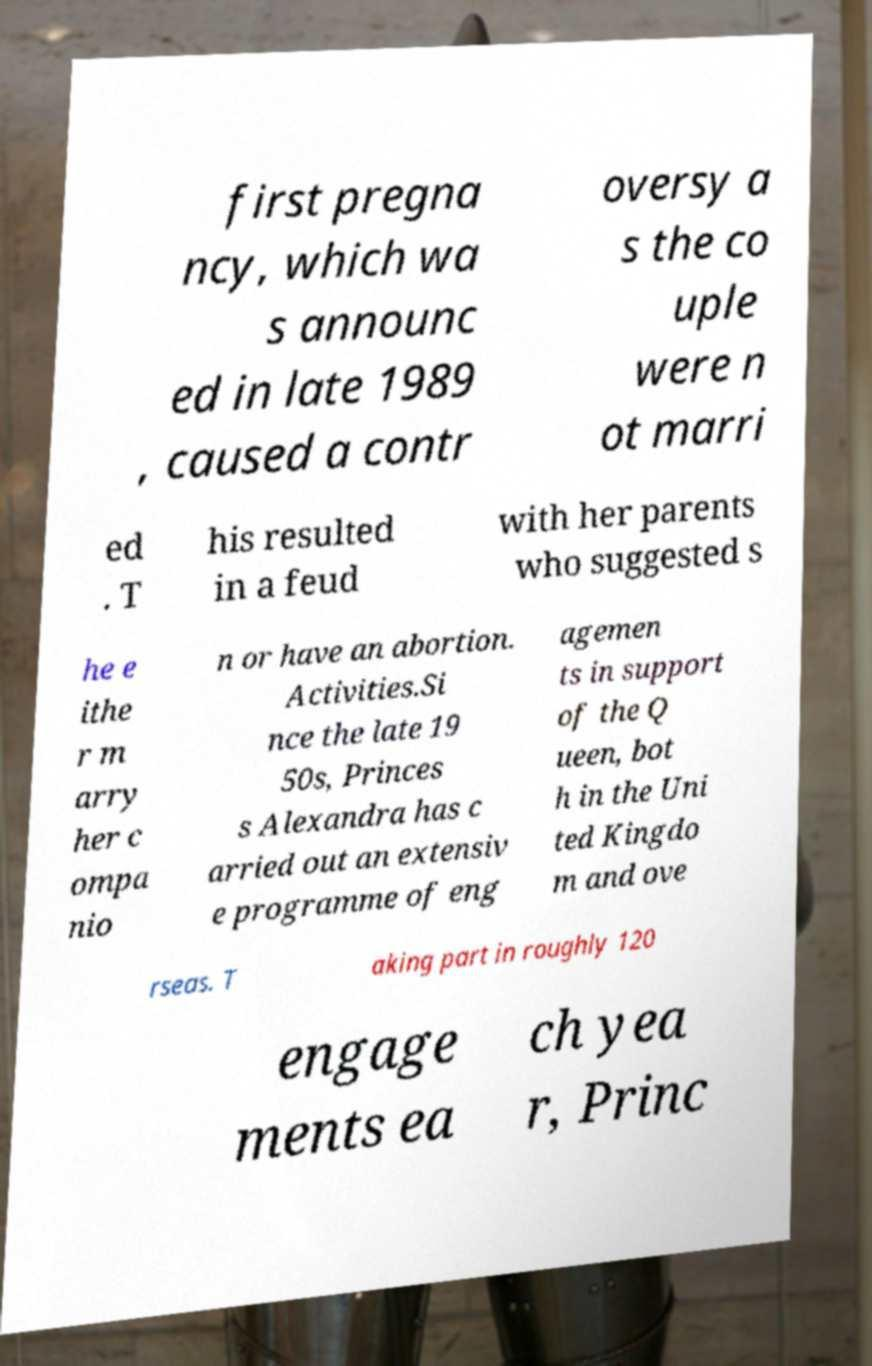Please read and relay the text visible in this image. What does it say? first pregna ncy, which wa s announc ed in late 1989 , caused a contr oversy a s the co uple were n ot marri ed . T his resulted in a feud with her parents who suggested s he e ithe r m arry her c ompa nio n or have an abortion. Activities.Si nce the late 19 50s, Princes s Alexandra has c arried out an extensiv e programme of eng agemen ts in support of the Q ueen, bot h in the Uni ted Kingdo m and ove rseas. T aking part in roughly 120 engage ments ea ch yea r, Princ 